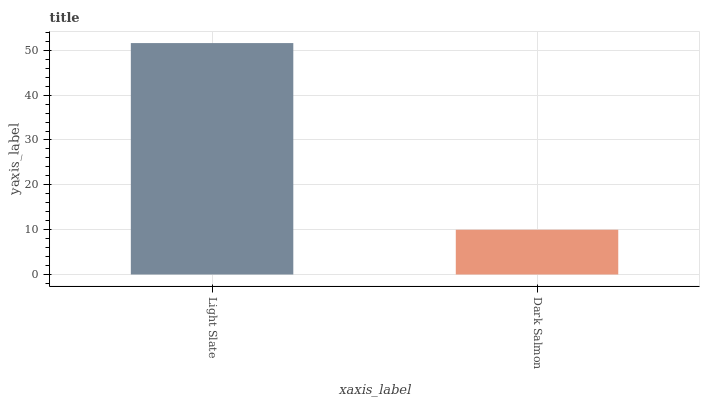Is Dark Salmon the maximum?
Answer yes or no. No. Is Light Slate greater than Dark Salmon?
Answer yes or no. Yes. Is Dark Salmon less than Light Slate?
Answer yes or no. Yes. Is Dark Salmon greater than Light Slate?
Answer yes or no. No. Is Light Slate less than Dark Salmon?
Answer yes or no. No. Is Light Slate the high median?
Answer yes or no. Yes. Is Dark Salmon the low median?
Answer yes or no. Yes. Is Dark Salmon the high median?
Answer yes or no. No. Is Light Slate the low median?
Answer yes or no. No. 